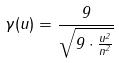Convert formula to latex. <formula><loc_0><loc_0><loc_500><loc_500>\gamma ( u ) = \frac { 9 } { \sqrt { 9 \cdot \frac { u ^ { 2 } } { n ^ { 2 } } } }</formula> 